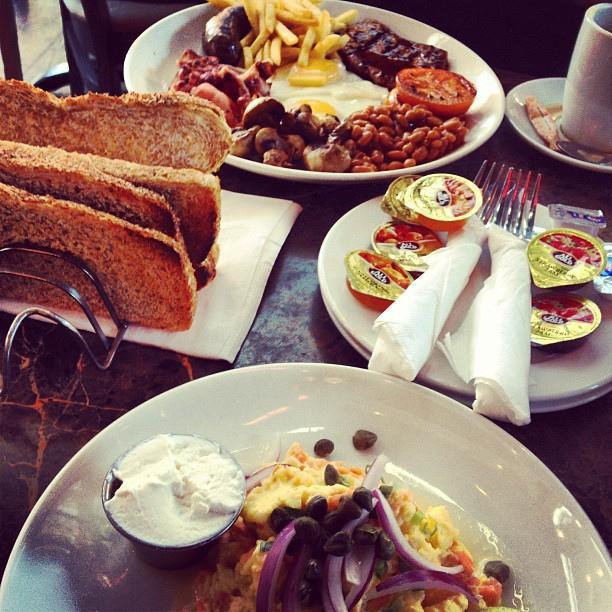How many pieces of bread are on the table?
Give a very brief answer. 4. How many bowls are in the photo?
Give a very brief answer. 1. How many dining tables can be seen?
Give a very brief answer. 1. How many sandwiches are visible?
Give a very brief answer. 1. 